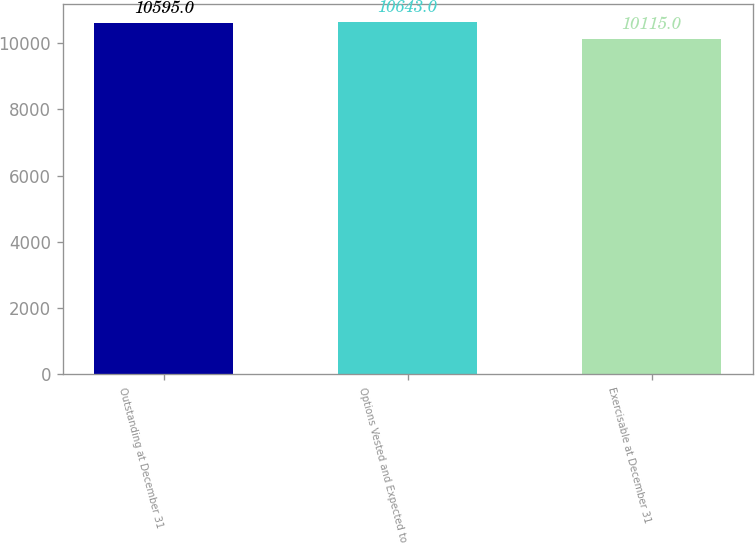Convert chart. <chart><loc_0><loc_0><loc_500><loc_500><bar_chart><fcel>Outstanding at December 31<fcel>Options Vested and Expected to<fcel>Exercisable at December 31<nl><fcel>10595<fcel>10643<fcel>10115<nl></chart> 